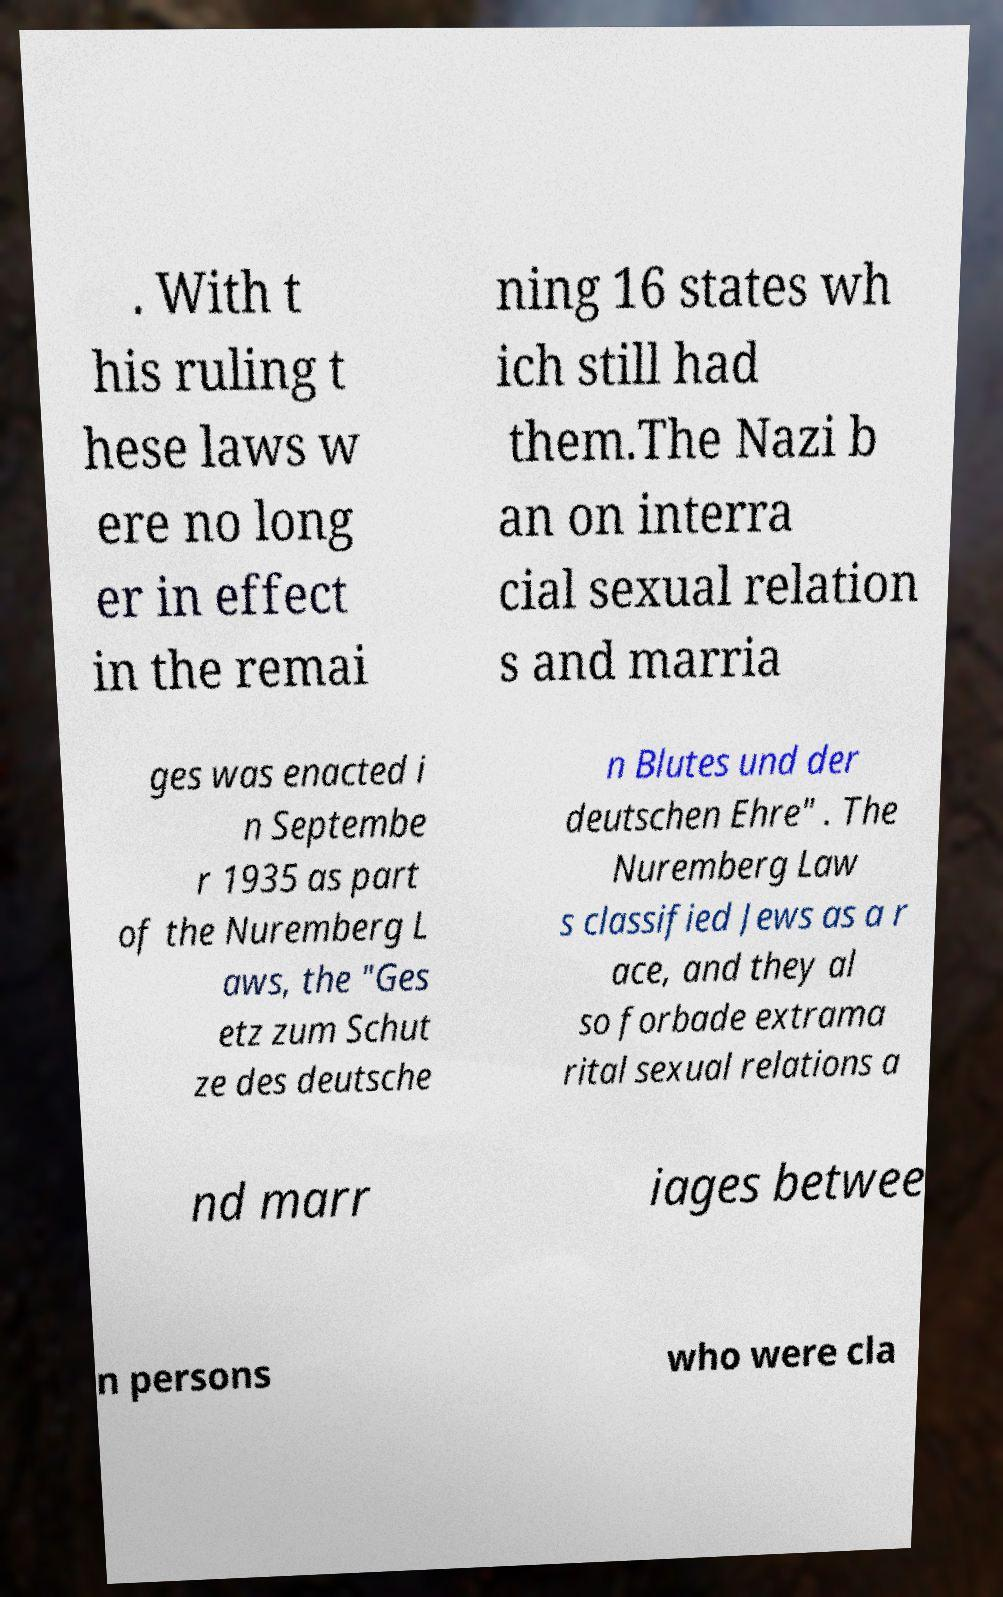Please identify and transcribe the text found in this image. . With t his ruling t hese laws w ere no long er in effect in the remai ning 16 states wh ich still had them.The Nazi b an on interra cial sexual relation s and marria ges was enacted i n Septembe r 1935 as part of the Nuremberg L aws, the "Ges etz zum Schut ze des deutsche n Blutes und der deutschen Ehre" . The Nuremberg Law s classified Jews as a r ace, and they al so forbade extrama rital sexual relations a nd marr iages betwee n persons who were cla 